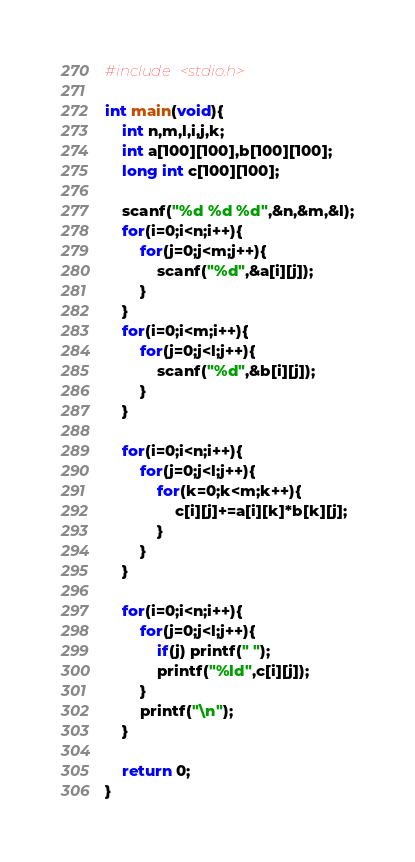<code> <loc_0><loc_0><loc_500><loc_500><_C_>#include <stdio.h>

int main(void){
	int n,m,l,i,j,k;
	int a[100][100],b[100][100];
	long int c[100][100];
	
	scanf("%d %d %d",&n,&m,&l);
	for(i=0;i<n;i++){
		for(j=0;j<m;j++){
			scanf("%d",&a[i][j]);
		}
	}
	for(i=0;i<m;i++){
		for(j=0;j<l;j++){
			scanf("%d",&b[i][j]);
		}
	}
	
	for(i=0;i<n;i++){
		for(j=0;j<l;j++){
			for(k=0;k<m;k++){
				c[i][j]+=a[i][k]*b[k][j];
			}
		}
	}
	
	for(i=0;i<n;i++){
		for(j=0;j<l;j++){
			if(j) printf(" ");
			printf("%ld",c[i][j]);
		}
		printf("\n");
	}
	
	return 0;
}</code> 